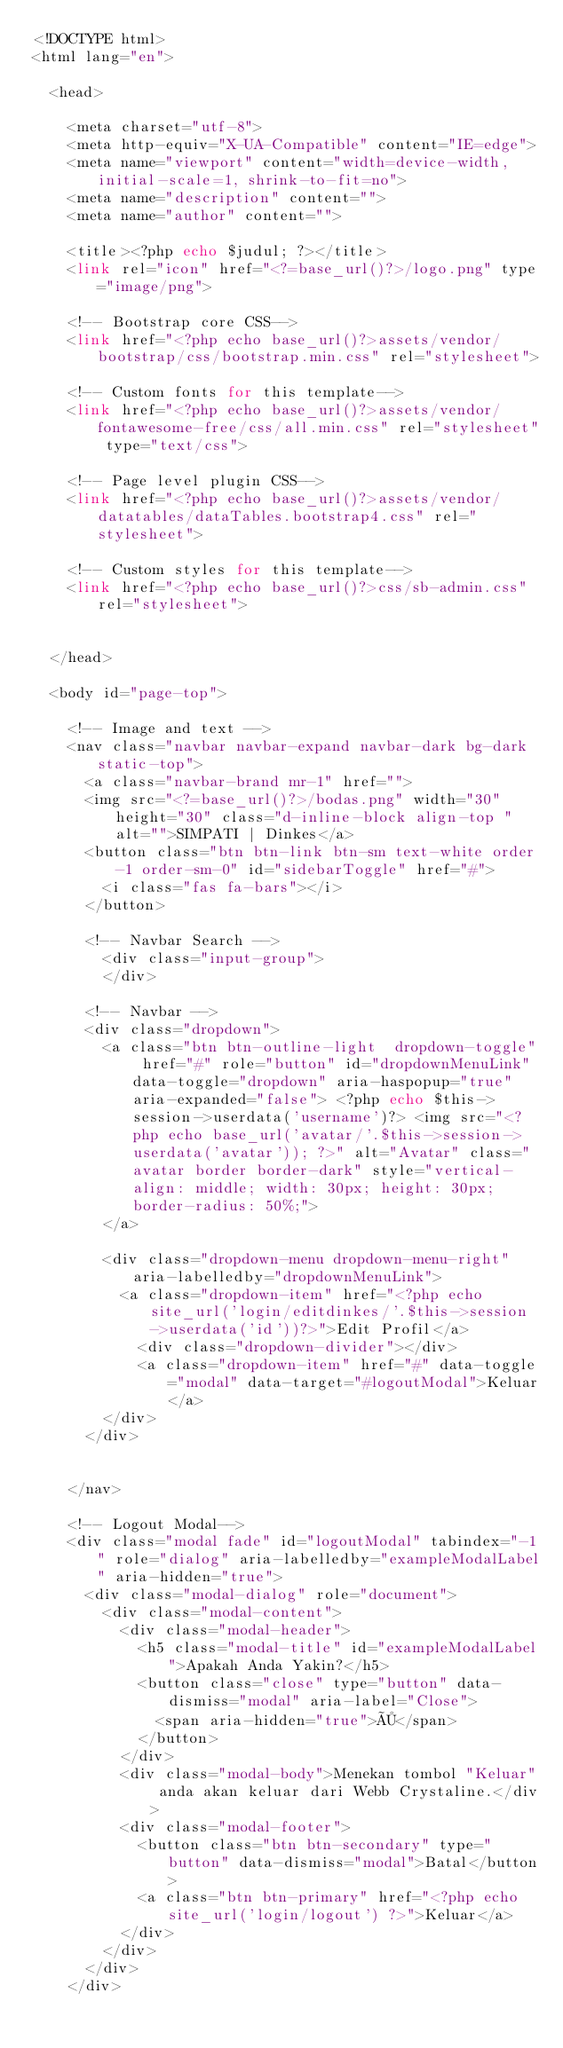<code> <loc_0><loc_0><loc_500><loc_500><_PHP_><!DOCTYPE html>
<html lang="en">

  <head>

    <meta charset="utf-8">
    <meta http-equiv="X-UA-Compatible" content="IE=edge">
    <meta name="viewport" content="width=device-width, initial-scale=1, shrink-to-fit=no">
    <meta name="description" content="">
    <meta name="author" content="">

    <title><?php echo $judul; ?></title>
    <link rel="icon" href="<?=base_url()?>/logo.png" type="image/png">

    <!-- Bootstrap core CSS-->
    <link href="<?php echo base_url()?>assets/vendor/bootstrap/css/bootstrap.min.css" rel="stylesheet">

    <!-- Custom fonts for this template-->
    <link href="<?php echo base_url()?>assets/vendor/fontawesome-free/css/all.min.css" rel="stylesheet" type="text/css">

    <!-- Page level plugin CSS-->
    <link href="<?php echo base_url()?>assets/vendor/datatables/dataTables.bootstrap4.css" rel="stylesheet">

    <!-- Custom styles for this template-->
    <link href="<?php echo base_url()?>css/sb-admin.css" rel="stylesheet">


  </head>

  <body id="page-top">

    <!-- Image and text -->  
    <nav class="navbar navbar-expand navbar-dark bg-dark static-top">
      <a class="navbar-brand mr-1" href="">
      <img src="<?=base_url()?>/bodas.png" width="30" height="30" class="d-inline-block align-top " alt="">SIMPATI | Dinkes</a>
      <button class="btn btn-link btn-sm text-white order-1 order-sm-0" id="sidebarToggle" href="#">
        <i class="fas fa-bars"></i>
      </button>

      <!-- Navbar Search -->
        <div class="input-group">
        </div>

      <!-- Navbar -->
      <div class="dropdown">
        <a class="btn btn-outline-light  dropdown-toggle" href="#" role="button" id="dropdownMenuLink" data-toggle="dropdown" aria-haspopup="true" aria-expanded="false"> <?php echo $this->session->userdata('username')?> <img src="<?php echo base_url('avatar/'.$this->session->userdata('avatar')); ?>" alt="Avatar" class="avatar border border-dark" style="vertical-align: middle; width: 30px; height: 30px; border-radius: 50%;"> 
        </a>

        <div class="dropdown-menu dropdown-menu-right" aria-labelledby="dropdownMenuLink">
          <a class="dropdown-item" href="<?php echo site_url('login/editdinkes/'.$this->session->userdata('id'))?>">Edit Profil</a>
            <div class="dropdown-divider"></div>
            <a class="dropdown-item" href="#" data-toggle="modal" data-target="#logoutModal">Keluar</a>
        </div>
      </div>

      
    </nav>

    <!-- Logout Modal-->
    <div class="modal fade" id="logoutModal" tabindex="-1" role="dialog" aria-labelledby="exampleModalLabel" aria-hidden="true">
      <div class="modal-dialog" role="document">
        <div class="modal-content">
          <div class="modal-header">
            <h5 class="modal-title" id="exampleModalLabel">Apakah Anda Yakin?</h5>
            <button class="close" type="button" data-dismiss="modal" aria-label="Close">
              <span aria-hidden="true">×</span>
            </button>
          </div>
          <div class="modal-body">Menekan tombol "Keluar" anda akan keluar dari Webb Crystaline.</div>
          <div class="modal-footer">
            <button class="btn btn-secondary" type="button" data-dismiss="modal">Batal</button>
            <a class="btn btn-primary" href="<?php echo site_url('login/logout') ?>">Keluar</a>
          </div>
        </div>
      </div>
    </div>
</code> 